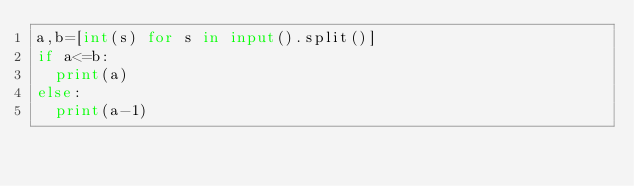Convert code to text. <code><loc_0><loc_0><loc_500><loc_500><_Python_>a,b=[int(s) for s in input().split()]
if a<=b:
  print(a)
else:
  print(a-1)</code> 